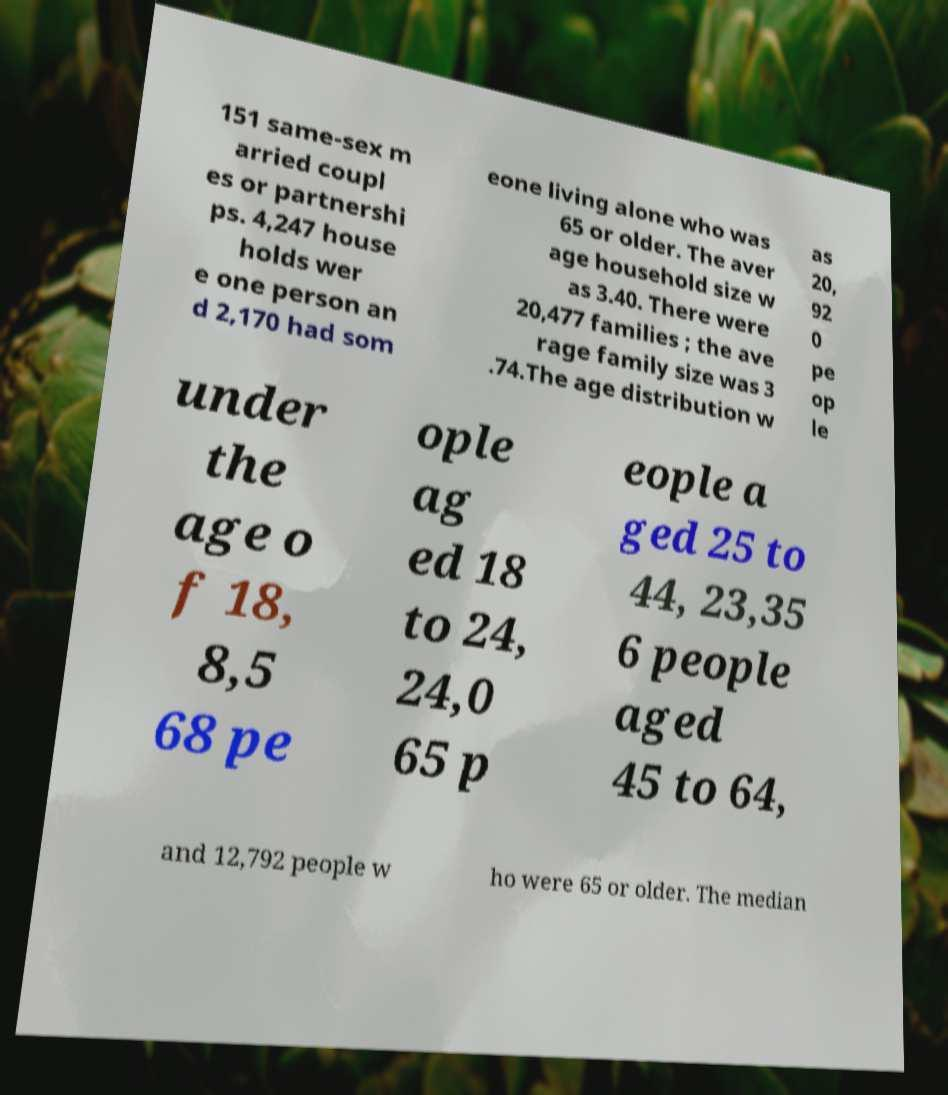I need the written content from this picture converted into text. Can you do that? 151 same-sex m arried coupl es or partnershi ps. 4,247 house holds wer e one person an d 2,170 had som eone living alone who was 65 or older. The aver age household size w as 3.40. There were 20,477 families ; the ave rage family size was 3 .74.The age distribution w as 20, 92 0 pe op le under the age o f 18, 8,5 68 pe ople ag ed 18 to 24, 24,0 65 p eople a ged 25 to 44, 23,35 6 people aged 45 to 64, and 12,792 people w ho were 65 or older. The median 